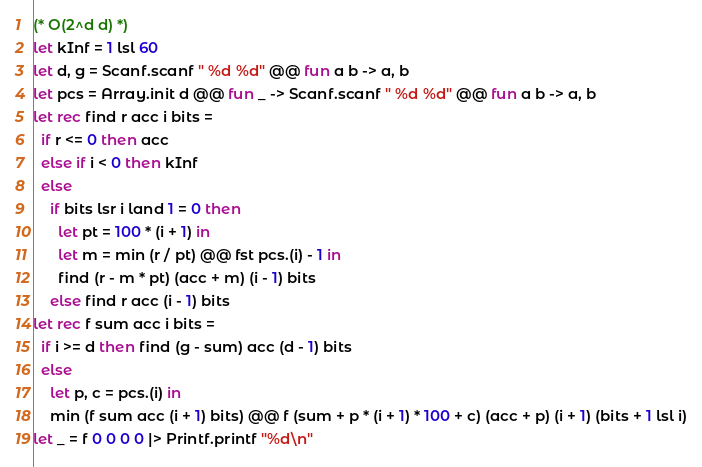Convert code to text. <code><loc_0><loc_0><loc_500><loc_500><_OCaml_>(* O(2^d d) *)
let kInf = 1 lsl 60
let d, g = Scanf.scanf " %d %d" @@ fun a b -> a, b
let pcs = Array.init d @@ fun _ -> Scanf.scanf " %d %d" @@ fun a b -> a, b
let rec find r acc i bits =
  if r <= 0 then acc
  else if i < 0 then kInf
  else
    if bits lsr i land 1 = 0 then
      let pt = 100 * (i + 1) in
      let m = min (r / pt) @@ fst pcs.(i) - 1 in
      find (r - m * pt) (acc + m) (i - 1) bits
    else find r acc (i - 1) bits
let rec f sum acc i bits =
  if i >= d then find (g - sum) acc (d - 1) bits
  else
    let p, c = pcs.(i) in
    min (f sum acc (i + 1) bits) @@ f (sum + p * (i + 1) * 100 + c) (acc + p) (i + 1) (bits + 1 lsl i)
let _ = f 0 0 0 0 |> Printf.printf "%d\n"</code> 